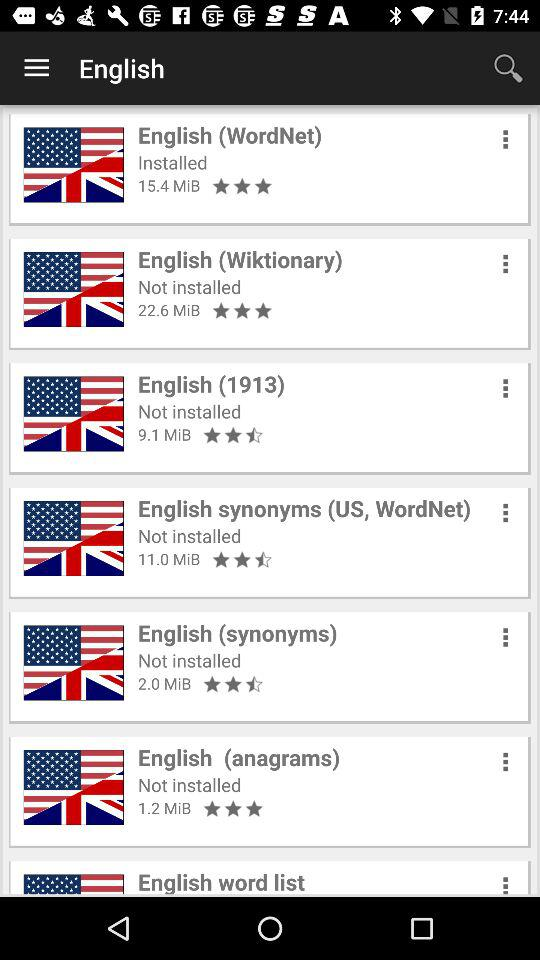What is the rating of the "English (anagrams)" app? The rating of the "English (anagrams)" app is 3 stars. 